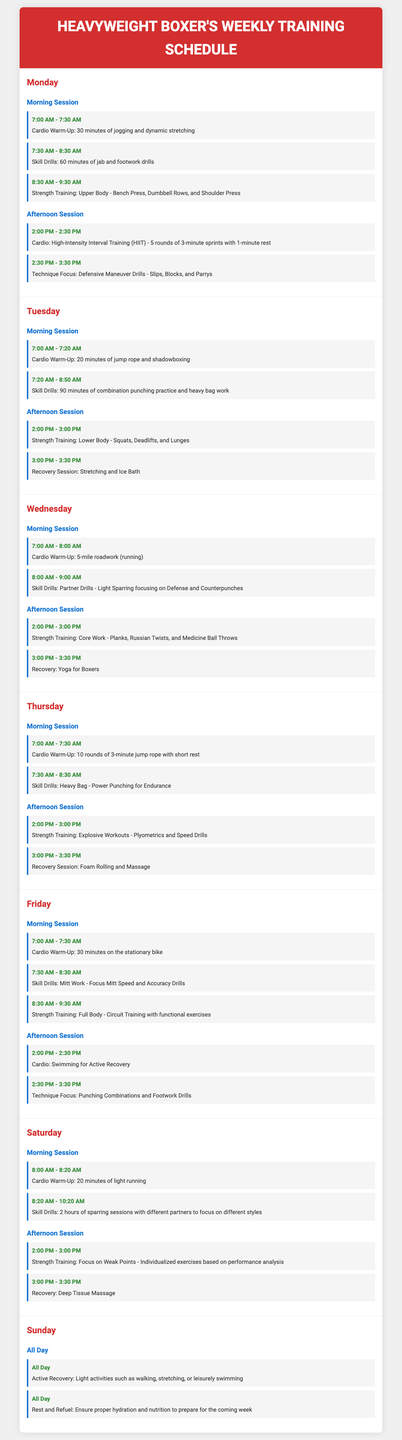what time does the Monday morning cardio warm-up start? The cardio warm-up on Monday starts at 7:00 AM.
Answer: 7:00 AM how long is the Tuesday morning skill drills session? The Tuesday morning skill drills session lasts for 90 minutes.
Answer: 90 minutes what type of recovery session is scheduled for Tuesday afternoon? The Tuesday afternoon recovery session involves stretching and an ice bath.
Answer: Stretching and Ice Bath how many rounds of jump rope are included in Thursday morning's cardio warm-up? Thursday's cardio warm-up includes 10 rounds of jump rope.
Answer: 10 rounds what is the main focus of the Saturday morning skill drills? The main focus of the Saturday morning skill drills is sparring sessions with different partners.
Answer: Sparring sessions which day includes a full day of active recovery? Sunday includes a full day of active recovery.
Answer: Sunday in which session does the strength training for the core take place? The strength training for the core takes place in the Wednesday afternoon session.
Answer: Wednesday afternoon session how many minutes is the Friday afternoon cardio session? The Friday afternoon cardio session lasts for 30 minutes.
Answer: 30 minutes 